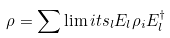<formula> <loc_0><loc_0><loc_500><loc_500>\rho = \sum \lim i t s _ { l } E _ { l } \rho _ { i } E _ { l } ^ { \dag }</formula> 